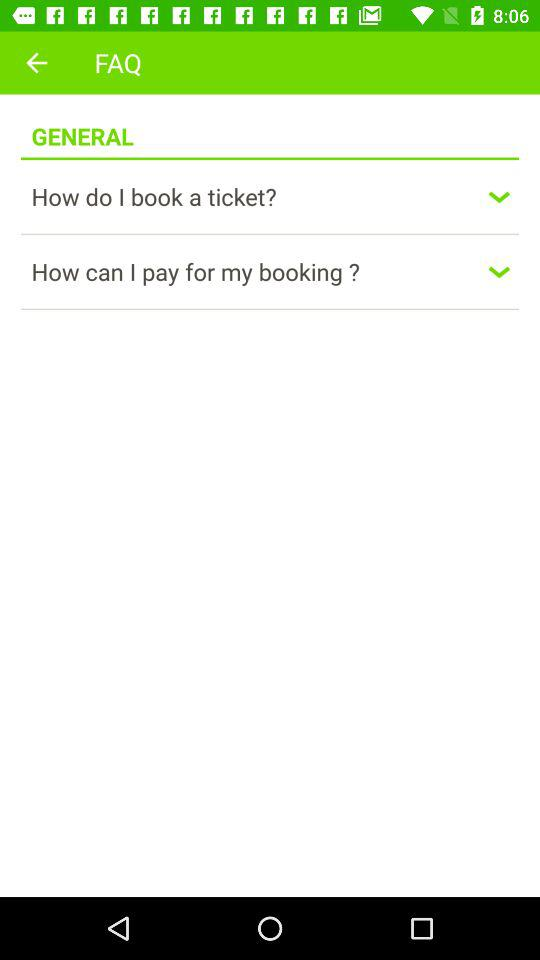How many FAQs are there in total?
Answer the question using a single word or phrase. 2 